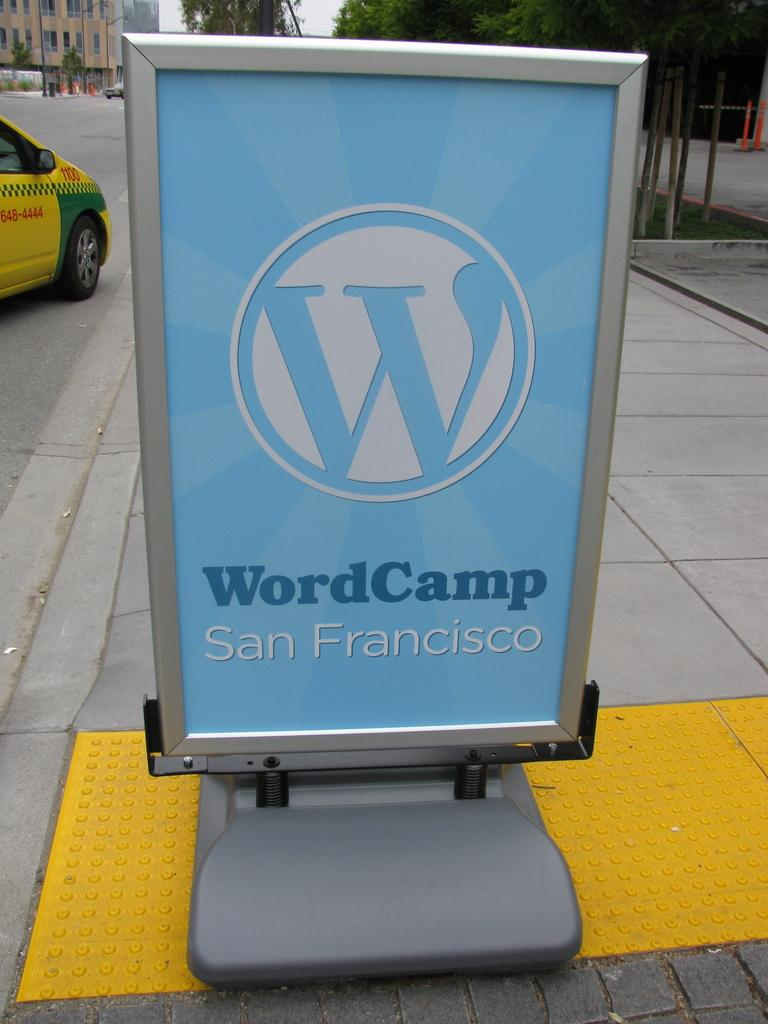<image>
Give a short and clear explanation of the subsequent image. A light blue sign on a sidewalk says WordCamp San Francisco. 